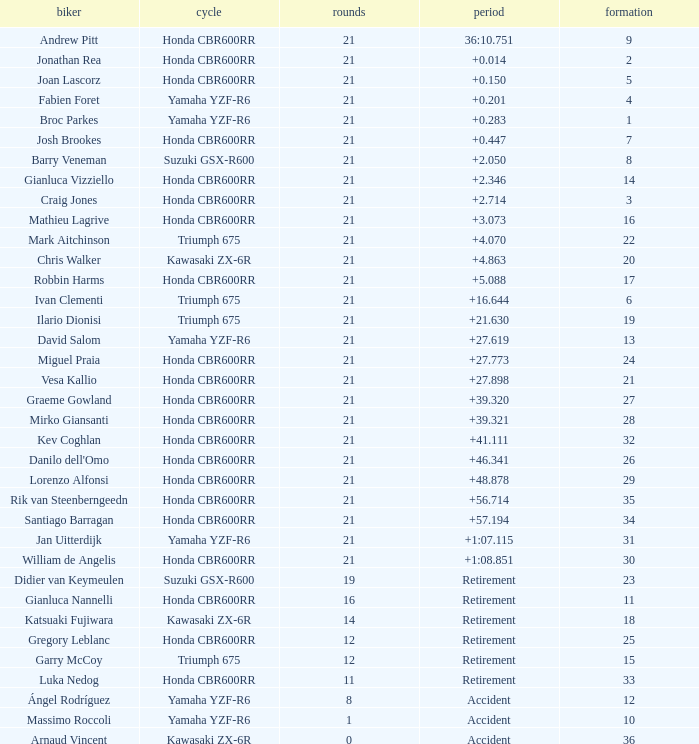What is the total of laps run by the driver with a grid under 17 and a time of +5.088? None. 